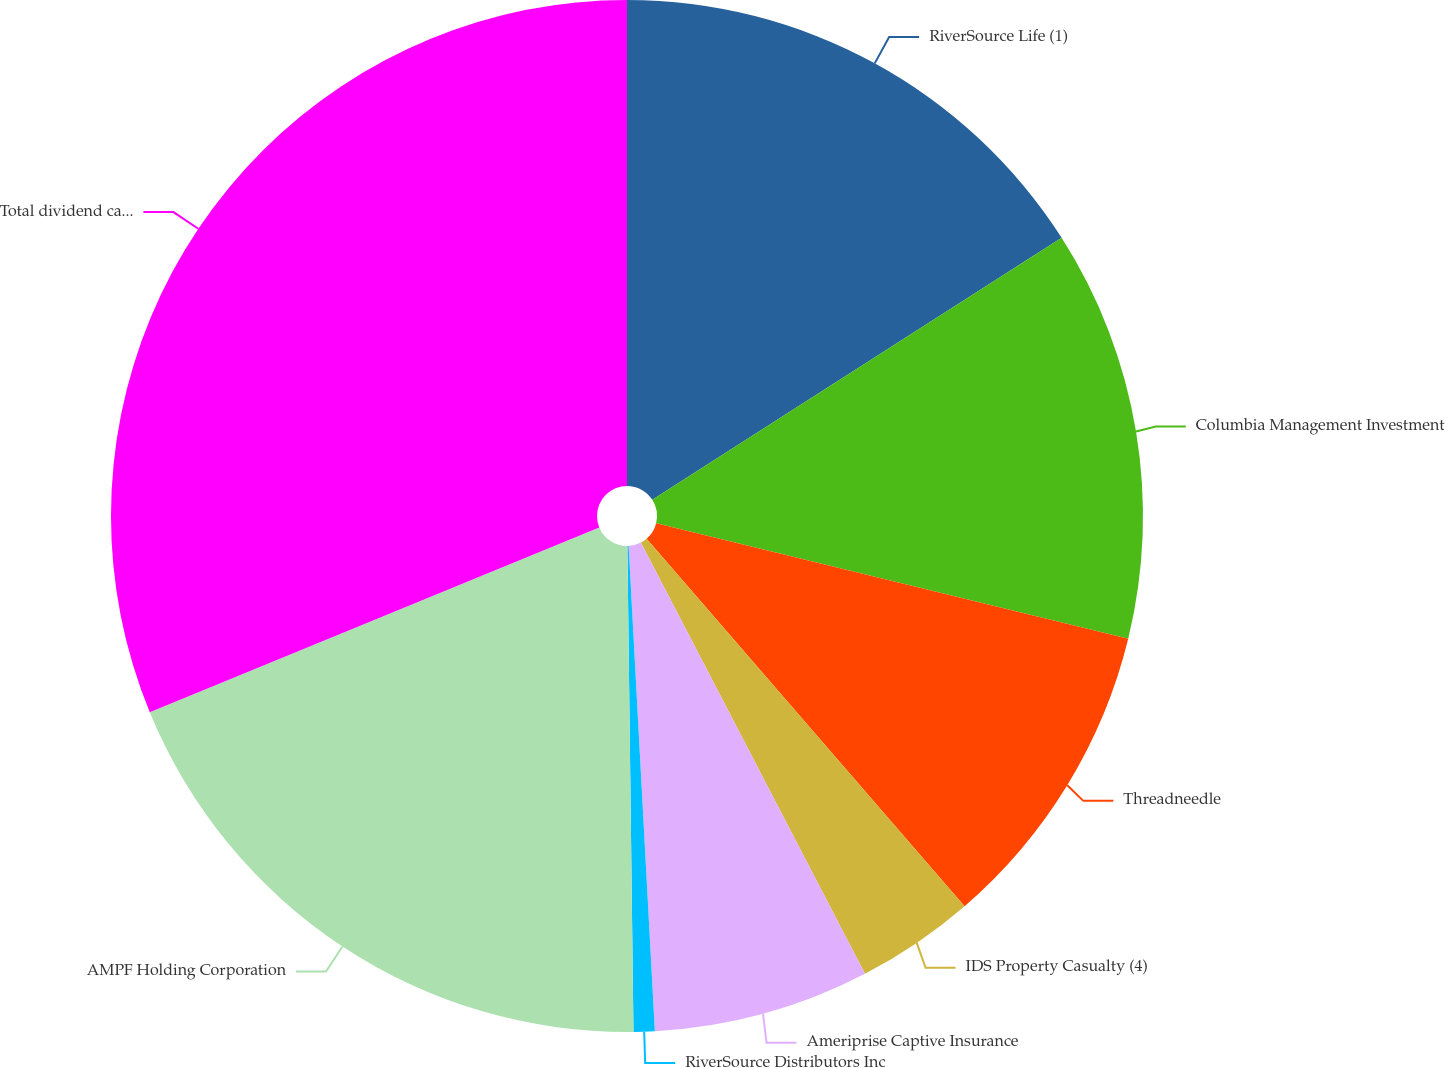Convert chart to OTSL. <chart><loc_0><loc_0><loc_500><loc_500><pie_chart><fcel>RiverSource Life (1)<fcel>Columbia Management Investment<fcel>Threadneedle<fcel>IDS Property Casualty (4)<fcel>Ameriprise Captive Insurance<fcel>RiverSource Distributors Inc<fcel>AMPF Holding Corporation<fcel>Total dividend capacity<nl><fcel>15.94%<fcel>12.88%<fcel>9.83%<fcel>3.72%<fcel>6.77%<fcel>0.66%<fcel>18.99%<fcel>31.21%<nl></chart> 